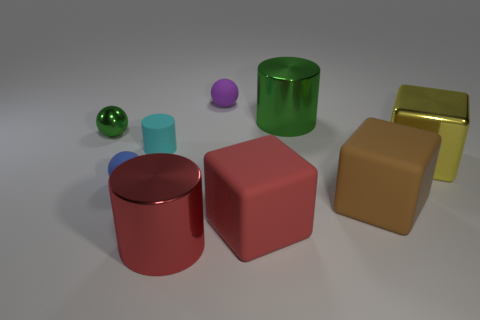There is a green shiny thing right of the green sphere; what is its size?
Your answer should be compact. Large. There is a green object that is behind the metal thing that is to the left of the metal thing that is in front of the large brown cube; what shape is it?
Offer a very short reply. Cylinder. There is a shiny thing that is both to the right of the blue rubber ball and behind the tiny cyan rubber thing; what is its shape?
Your answer should be very brief. Cylinder. Is there a yellow cylinder that has the same size as the green metal cylinder?
Give a very brief answer. No. Do the green object that is to the right of the tiny purple matte object and the blue thing have the same shape?
Your answer should be compact. No. Do the large red rubber thing and the red shiny thing have the same shape?
Your answer should be compact. No. Are there any other cyan rubber things of the same shape as the tiny cyan object?
Make the answer very short. No. There is a tiny object behind the tiny object to the left of the small blue matte thing; what shape is it?
Provide a short and direct response. Sphere. What color is the big cylinder behind the small blue sphere?
Your answer should be compact. Green. The red thing that is the same material as the tiny blue ball is what size?
Provide a succinct answer. Large. 